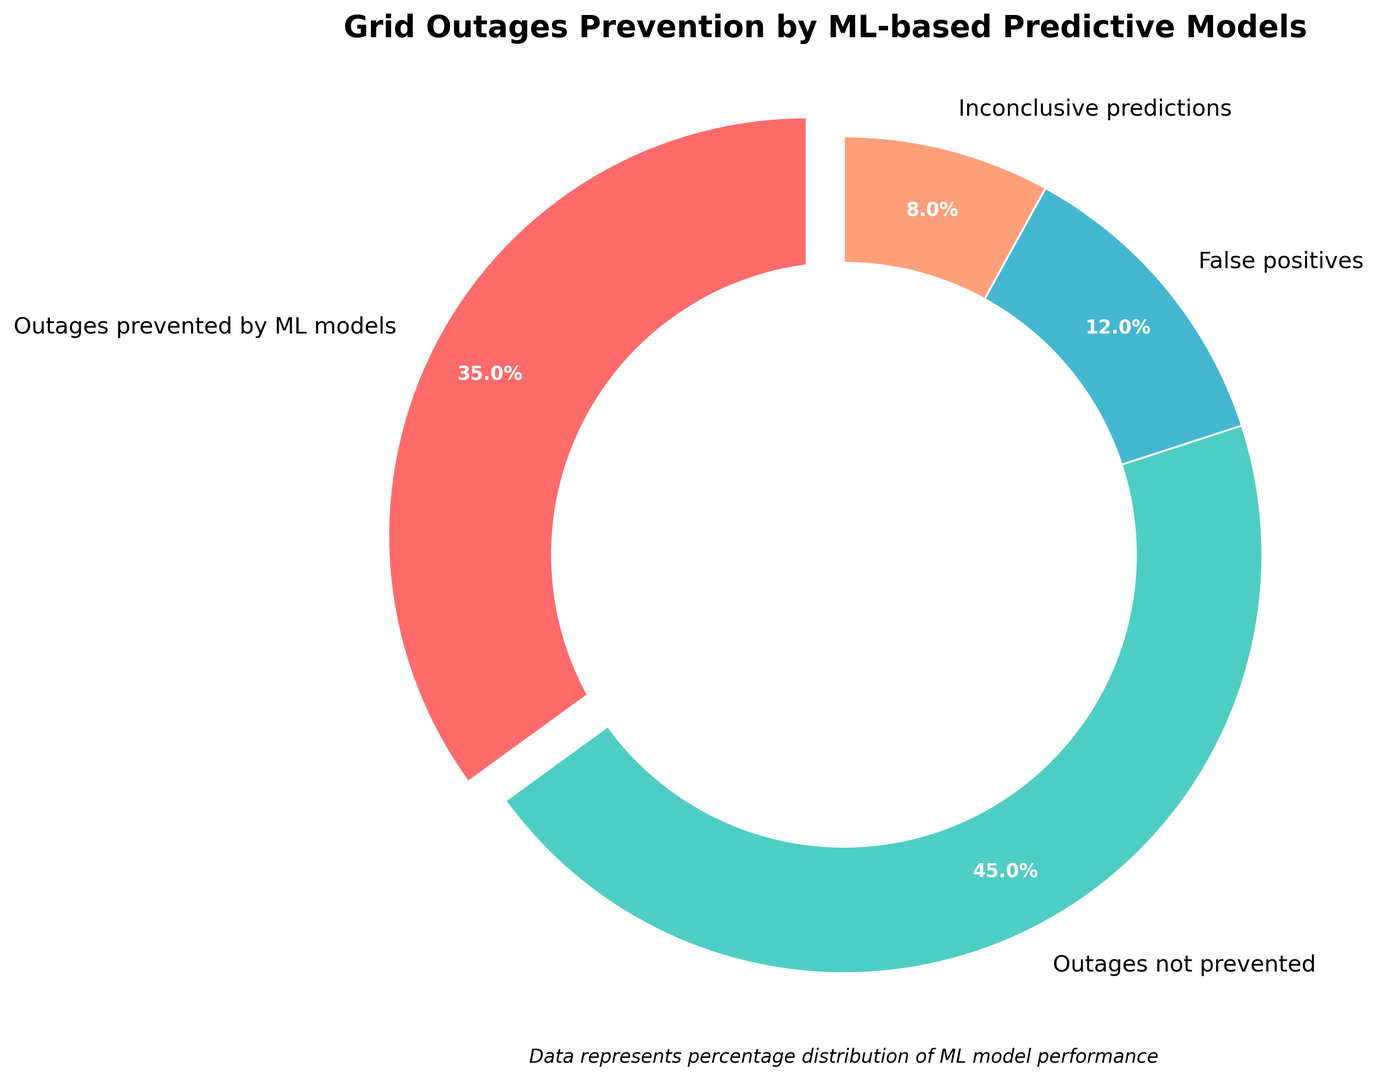Which category has the highest percentage of grid outages? The categories and their percentages are displayed in the pie chart. The "Outages not prevented" segment has the largest area in the chart, indicating it represents the highest percentage.
Answer: Outages not prevented What is the combined percentage of inconclusive predictions and false positives? To find the combined percentage, add the percentage of inconclusive predictions (8%) and false positives (12%). So, 8% + 12% = 20%.
Answer: 20% How much more effective is the ML model at preventing outages compared to the falsely positive predictions it generates? First, determine the percentage of outages prevented by the ML model (35%) and the percentage of false positives (12%). Then, subtract the percentage of false positives from the percentage of outages prevented: 35% - 12% = 23%.
Answer: 23% What percentage of total predictions are conclusive? Conclusive predictions include both "Outages prevented by ML models" (35%) and "Outages not prevented" (45%). Add these percentages: 35% + 45% = 80%.
Answer: 80% Which color represents the false positives category in the pie chart? The pie chart uses different colors for each category. The false positives are represented by the green colored segment on the chart.
Answer: Green By how much does the percentage of outages not prevented exceed the percentage of outages prevented by ML models? The percentage of outages not prevented is 45%, and the percentage of outages prevented by ML models is 35%. Subtract the percentage of outages prevented from the percentage of outages not prevented: 45% - 35% = 10%.
Answer: 10% What is the visual cue used to emphasize the "Outages prevented by ML models" category in the pie chart? Visual emphasis on this category is achieved by "exploding" or slightly separating the wedge from the rest of the pie chart.
Answer: Explosion/Separation What is the relationship between inconclusive predictions and total false positives? Inconclusive predictions represent 8%, and false positives represent 12%. To find the relationship, compare the two percentages: 8% is less than 12%, so inconclusive predictions are less than total false positives by 4%.
Answer: Less by 4% Which category has the smallest percentage in the pie chart? The pie chart depicts each category's percentage. The "Inconclusive predictions" segment is the smallest, indicating it represents the smallest percentage.
Answer: Inconclusive predictions 